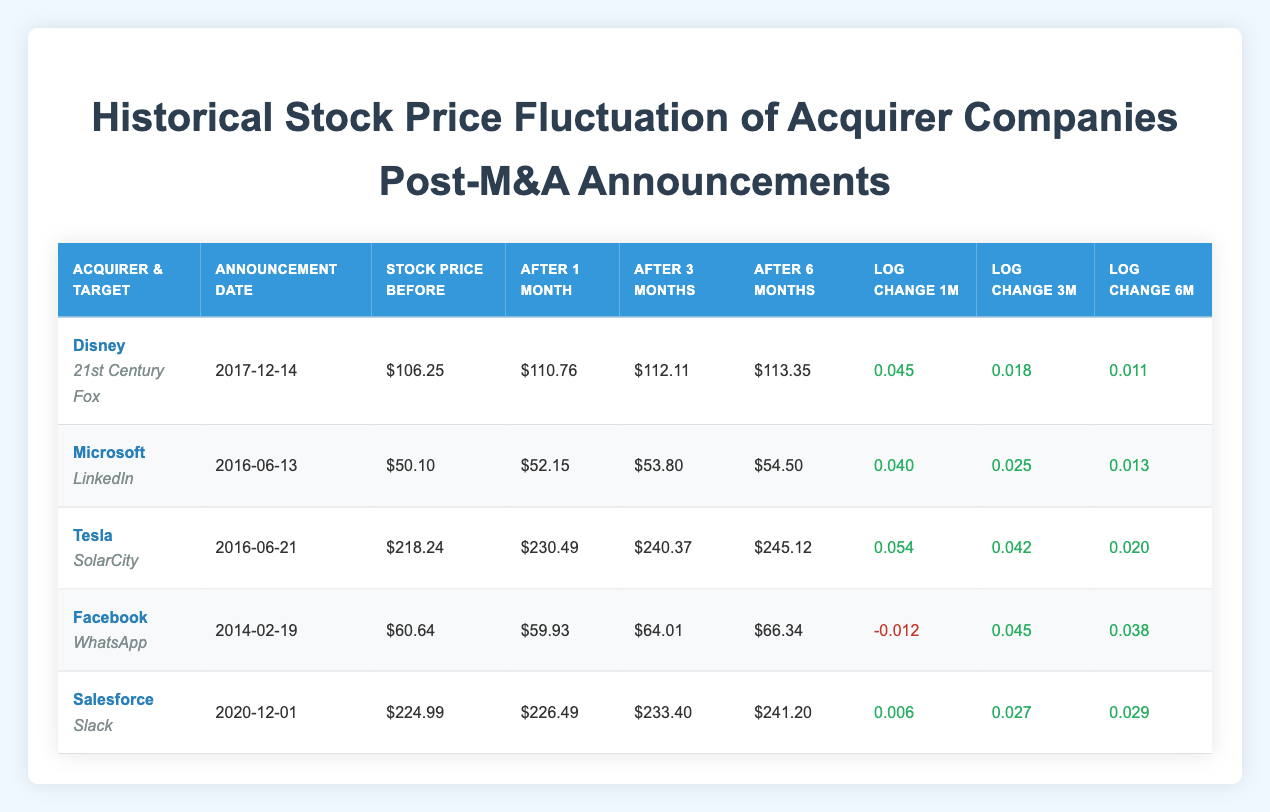What is the stock price of Disney after 1 month of the M&A announcement? The table shows that Disney's stock price after 1 month of the M&A announcement was $110.76.
Answer: $110.76 Which acquirer saw the highest stock price increase after 1 month? By comparing the 1-month stock price changes, Tesla's log change of 0.054 indicates the highest increase, while others like Facebook had a decrease.
Answer: Tesla What was Facebook's stock price change after 6 months post-announcement? According to the table, Facebook's stock price after 6 months post-announcement was $66.34.
Answer: $66.34 What is the average log price change after 3 months for all acquirers? The log price changes after 3 months are: 0.018 (Disney), 0.025 (Microsoft), 0.042 (Tesla), 0.045 (Facebook), and 0.027 (Salesforce). Adding these values: 0.018 + 0.025 + 0.042 + 0.045 + 0.027 = 0.157. Dividing by 5 gives us the average: 0.157 / 5 = 0.0314.
Answer: 0.0314 Did Microsoft’s stock price increase or decrease after the M&A announcement? By checking the stock price before and after the announcement, Microsoft’s stock price increased from $50.10 to $52.15 after 1 month. Thus, it did increase.
Answer: Yes Which acquirer had the smallest log price change after 1 month? By examining the log price changes after 1 month, Salesforce has the smallest log price change of 0.006 compared to the others.
Answer: Salesforce 